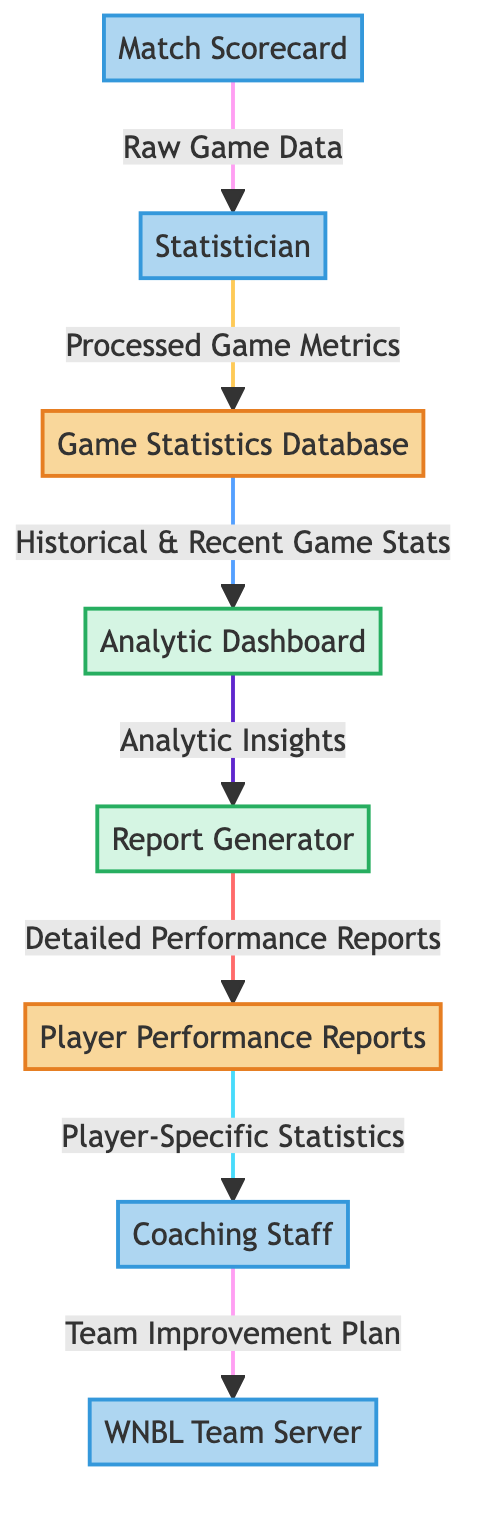What is the first entity in the data flow? The first entity in the data flow is the Match Scorecard which is marked as an external entity.
Answer: Match Scorecard How many processes are present in the diagram? There are two processes shown in the diagram: the Analytic Dashboard and the Report Generator.
Answer: 2 What is the last data flow in the diagram? The last data flow in the diagram is from the Coaching Staff to the WNBL Team Server, which transfers the Team Improvement Plan.
Answer: Team Improvement Plan Which entity receives the raw game data? The Statistician receives the raw game data from the Match Scorecard.
Answer: Statistician What type of data does the Game Statistics Database output to the Analytic Dashboard? The Game Statistics Database outputs Historical & Recent Game Stats to the Analytic Dashboard.
Answer: Historical & Recent Game Stats What is the main purpose of the Report Generator in the diagram? The main purpose of the Report Generator is to process Analytic Insights and produce Detailed Performance Reports.
Answer: Detailed Performance Reports Which external entity works directly with Player Performance Reports? The Coaching Staff works directly with Player Performance Reports by receiving Player-Specific Statistics.
Answer: Coaching Staff In the data flow, how many data stores are depicted? There are two data stores depicted in the diagram: the Game Statistics Database and Player Performance Reports.
Answer: 2 What kind of relationship exists between the Statistically and the Game Statistics Database? The relationship is that the Statistician processes game metrics and sends them to the Game Statistics Database.
Answer: Processed Game Metrics 